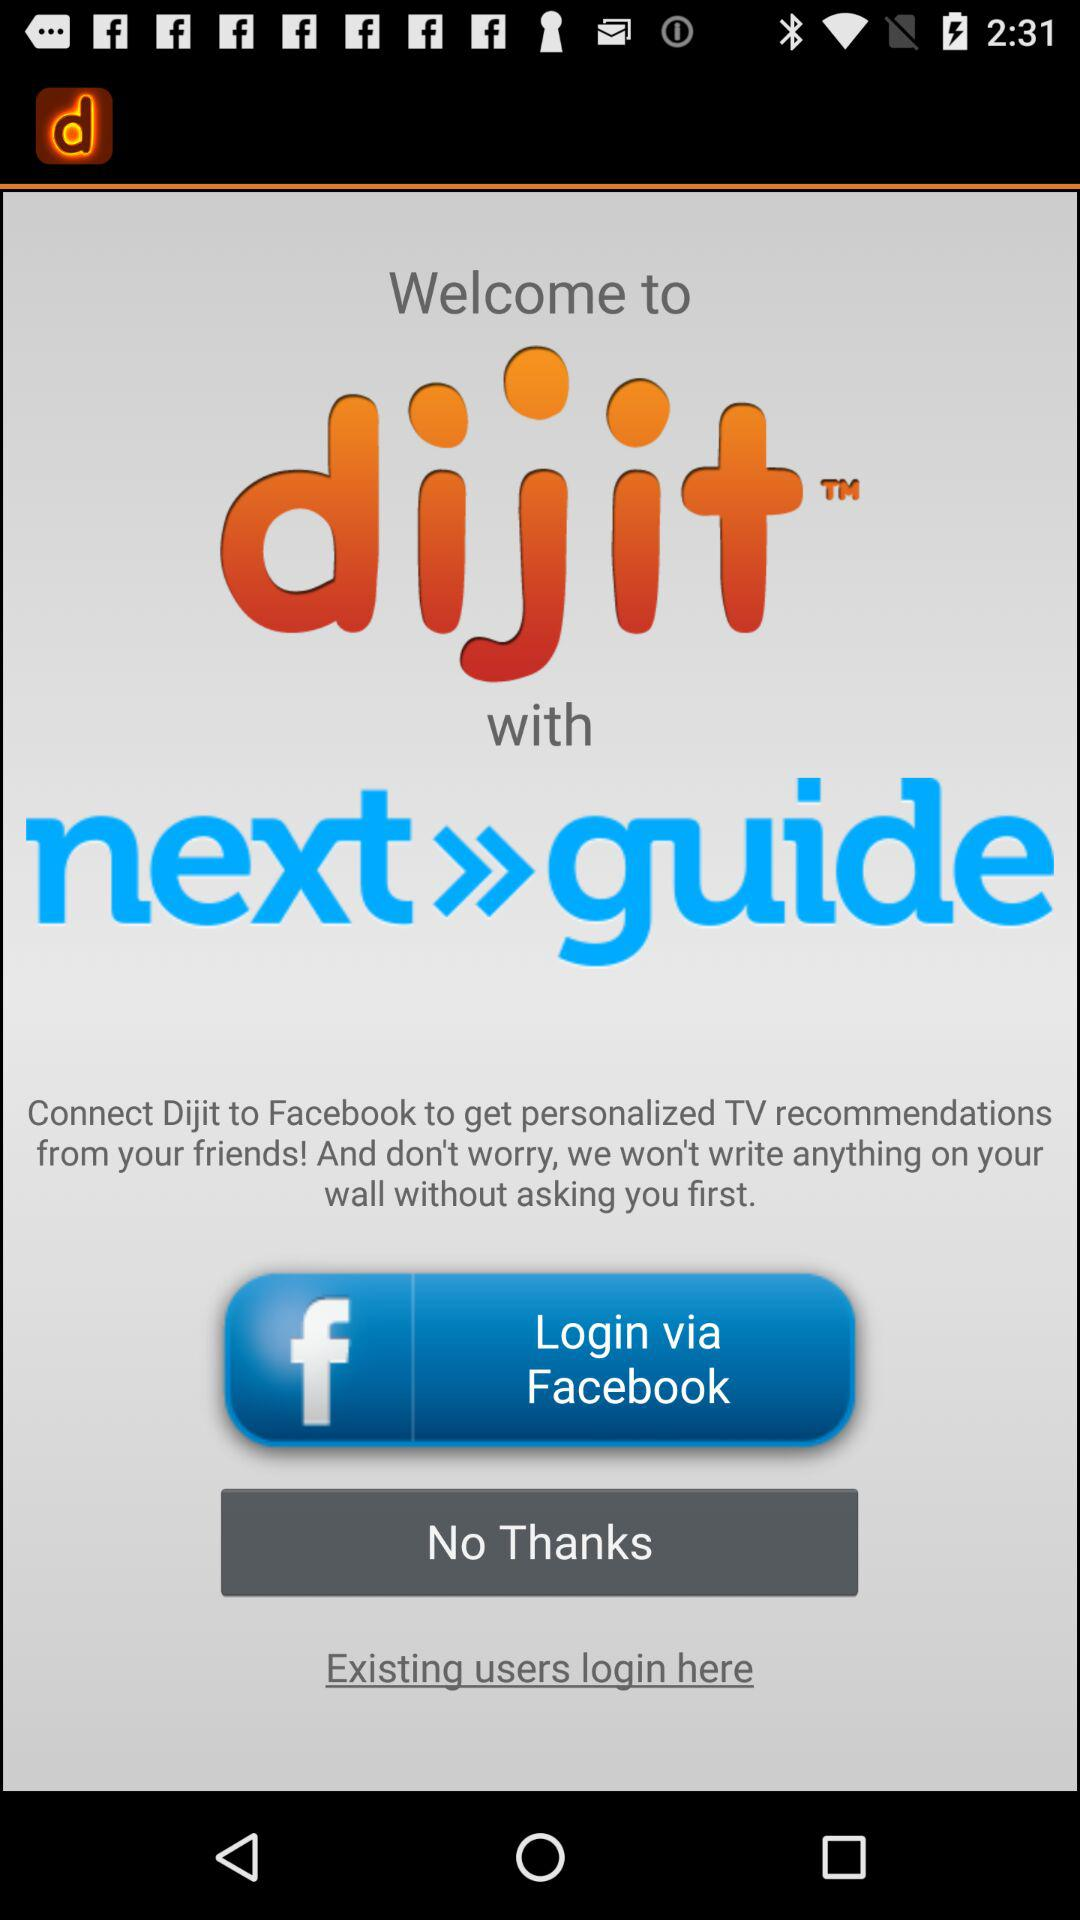What application can be used to log in with? The application that can be used to log in is "Facebook". 